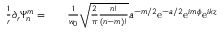<formula> <loc_0><loc_0><loc_500><loc_500>\begin{array} { r l r } { \frac { 1 } { r } \partial _ { r } \Psi _ { n } ^ { m } = } & { \frac { 1 } { w _ { 0 } } \sqrt { \frac { 2 } { \pi } \frac { n ! } { ( n - m ) ! } } a ^ { - m / 2 } e ^ { - a / 2 } e ^ { i m \phi } e ^ { i k z } } \end{array}</formula> 